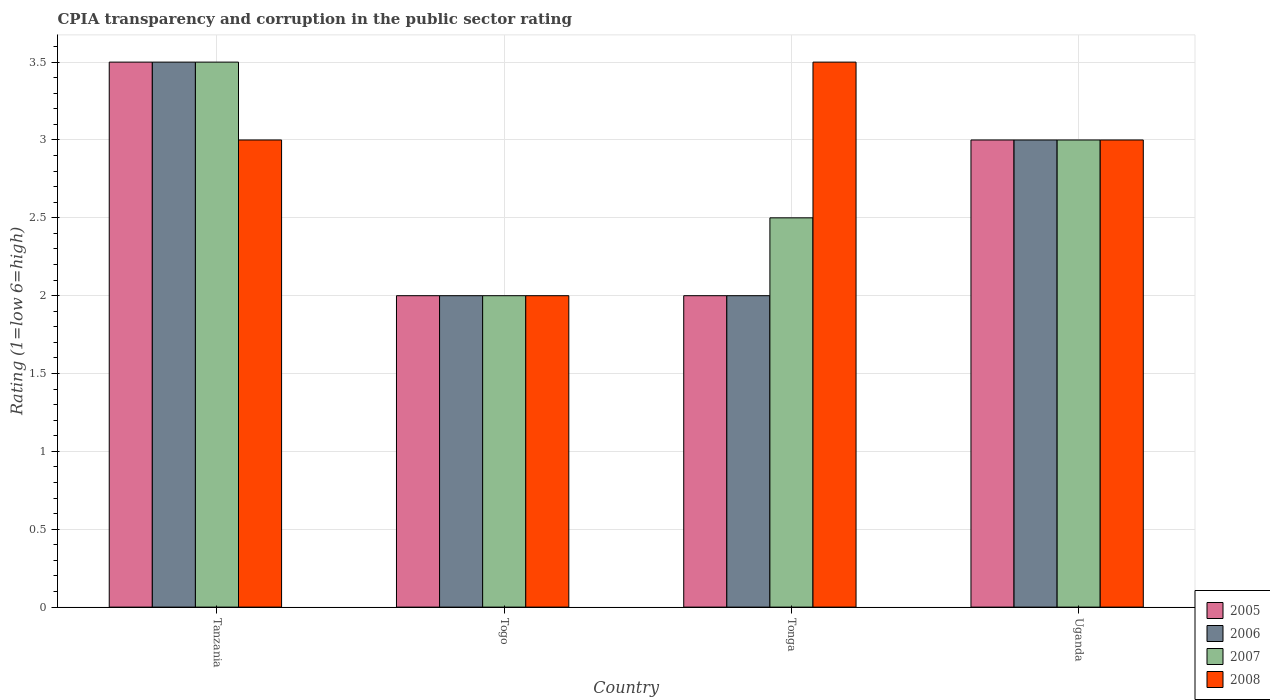How many groups of bars are there?
Offer a terse response. 4. Are the number of bars per tick equal to the number of legend labels?
Your answer should be very brief. Yes. What is the label of the 4th group of bars from the left?
Offer a very short reply. Uganda. In how many cases, is the number of bars for a given country not equal to the number of legend labels?
Give a very brief answer. 0. What is the CPIA rating in 2006 in Tonga?
Keep it short and to the point. 2. Across all countries, what is the minimum CPIA rating in 2008?
Your answer should be compact. 2. In which country was the CPIA rating in 2007 maximum?
Provide a succinct answer. Tanzania. In which country was the CPIA rating in 2007 minimum?
Your answer should be compact. Togo. What is the total CPIA rating in 2006 in the graph?
Keep it short and to the point. 10.5. What is the difference between the CPIA rating in 2005 in Tanzania and the CPIA rating in 2006 in Uganda?
Make the answer very short. 0.5. What is the average CPIA rating in 2007 per country?
Provide a succinct answer. 2.75. What is the difference between the CPIA rating of/in 2007 and CPIA rating of/in 2005 in Uganda?
Provide a short and direct response. 0. Is the difference between the CPIA rating in 2007 in Togo and Tonga greater than the difference between the CPIA rating in 2005 in Togo and Tonga?
Ensure brevity in your answer.  No. In how many countries, is the CPIA rating in 2007 greater than the average CPIA rating in 2007 taken over all countries?
Provide a short and direct response. 2. Is it the case that in every country, the sum of the CPIA rating in 2008 and CPIA rating in 2006 is greater than the sum of CPIA rating in 2007 and CPIA rating in 2005?
Make the answer very short. No. What does the 1st bar from the right in Tonga represents?
Provide a short and direct response. 2008. Is it the case that in every country, the sum of the CPIA rating in 2006 and CPIA rating in 2007 is greater than the CPIA rating in 2005?
Your answer should be compact. Yes. Are all the bars in the graph horizontal?
Make the answer very short. No. What is the difference between two consecutive major ticks on the Y-axis?
Offer a very short reply. 0.5. Does the graph contain any zero values?
Your response must be concise. No. Does the graph contain grids?
Ensure brevity in your answer.  Yes. What is the title of the graph?
Ensure brevity in your answer.  CPIA transparency and corruption in the public sector rating. What is the label or title of the X-axis?
Ensure brevity in your answer.  Country. What is the Rating (1=low 6=high) of 2006 in Tanzania?
Offer a very short reply. 3.5. What is the Rating (1=low 6=high) of 2005 in Togo?
Make the answer very short. 2. What is the Rating (1=low 6=high) of 2006 in Togo?
Provide a succinct answer. 2. What is the Rating (1=low 6=high) of 2007 in Togo?
Make the answer very short. 2. What is the Rating (1=low 6=high) of 2008 in Tonga?
Your answer should be very brief. 3.5. What is the Rating (1=low 6=high) of 2005 in Uganda?
Ensure brevity in your answer.  3. What is the Rating (1=low 6=high) of 2006 in Uganda?
Provide a short and direct response. 3. What is the Rating (1=low 6=high) in 2008 in Uganda?
Make the answer very short. 3. Across all countries, what is the maximum Rating (1=low 6=high) in 2008?
Make the answer very short. 3.5. Across all countries, what is the minimum Rating (1=low 6=high) in 2005?
Offer a terse response. 2. What is the difference between the Rating (1=low 6=high) in 2005 in Tanzania and that in Togo?
Your response must be concise. 1.5. What is the difference between the Rating (1=low 6=high) in 2007 in Tanzania and that in Togo?
Your answer should be very brief. 1.5. What is the difference between the Rating (1=low 6=high) of 2008 in Tanzania and that in Togo?
Provide a short and direct response. 1. What is the difference between the Rating (1=low 6=high) in 2006 in Tanzania and that in Tonga?
Offer a very short reply. 1.5. What is the difference between the Rating (1=low 6=high) of 2005 in Tanzania and that in Uganda?
Offer a terse response. 0.5. What is the difference between the Rating (1=low 6=high) in 2006 in Tanzania and that in Uganda?
Your answer should be very brief. 0.5. What is the difference between the Rating (1=low 6=high) in 2008 in Tanzania and that in Uganda?
Offer a terse response. 0. What is the difference between the Rating (1=low 6=high) in 2005 in Togo and that in Tonga?
Offer a terse response. 0. What is the difference between the Rating (1=low 6=high) in 2006 in Togo and that in Tonga?
Keep it short and to the point. 0. What is the difference between the Rating (1=low 6=high) of 2005 in Togo and that in Uganda?
Give a very brief answer. -1. What is the difference between the Rating (1=low 6=high) in 2006 in Togo and that in Uganda?
Provide a succinct answer. -1. What is the difference between the Rating (1=low 6=high) of 2008 in Togo and that in Uganda?
Your answer should be compact. -1. What is the difference between the Rating (1=low 6=high) of 2006 in Tonga and that in Uganda?
Your response must be concise. -1. What is the difference between the Rating (1=low 6=high) of 2005 in Tanzania and the Rating (1=low 6=high) of 2007 in Togo?
Give a very brief answer. 1.5. What is the difference between the Rating (1=low 6=high) of 2005 in Tanzania and the Rating (1=low 6=high) of 2008 in Togo?
Offer a very short reply. 1.5. What is the difference between the Rating (1=low 6=high) of 2006 in Tanzania and the Rating (1=low 6=high) of 2007 in Togo?
Your answer should be very brief. 1.5. What is the difference between the Rating (1=low 6=high) in 2005 in Tanzania and the Rating (1=low 6=high) in 2007 in Tonga?
Ensure brevity in your answer.  1. What is the difference between the Rating (1=low 6=high) in 2005 in Tanzania and the Rating (1=low 6=high) in 2008 in Tonga?
Offer a very short reply. 0. What is the difference between the Rating (1=low 6=high) of 2005 in Tanzania and the Rating (1=low 6=high) of 2007 in Uganda?
Offer a very short reply. 0.5. What is the difference between the Rating (1=low 6=high) of 2005 in Tanzania and the Rating (1=low 6=high) of 2008 in Uganda?
Provide a short and direct response. 0.5. What is the difference between the Rating (1=low 6=high) in 2006 in Tanzania and the Rating (1=low 6=high) in 2008 in Uganda?
Provide a short and direct response. 0.5. What is the difference between the Rating (1=low 6=high) of 2007 in Tanzania and the Rating (1=low 6=high) of 2008 in Uganda?
Provide a short and direct response. 0.5. What is the difference between the Rating (1=low 6=high) of 2006 in Togo and the Rating (1=low 6=high) of 2008 in Tonga?
Keep it short and to the point. -1.5. What is the difference between the Rating (1=low 6=high) of 2005 in Togo and the Rating (1=low 6=high) of 2007 in Uganda?
Keep it short and to the point. -1. What is the difference between the Rating (1=low 6=high) of 2005 in Togo and the Rating (1=low 6=high) of 2008 in Uganda?
Your response must be concise. -1. What is the difference between the Rating (1=low 6=high) in 2006 in Togo and the Rating (1=low 6=high) in 2007 in Uganda?
Make the answer very short. -1. What is the difference between the Rating (1=low 6=high) in 2006 in Togo and the Rating (1=low 6=high) in 2008 in Uganda?
Offer a terse response. -1. What is the difference between the Rating (1=low 6=high) of 2007 in Togo and the Rating (1=low 6=high) of 2008 in Uganda?
Make the answer very short. -1. What is the difference between the Rating (1=low 6=high) of 2005 in Tonga and the Rating (1=low 6=high) of 2006 in Uganda?
Ensure brevity in your answer.  -1. What is the difference between the Rating (1=low 6=high) of 2005 in Tonga and the Rating (1=low 6=high) of 2007 in Uganda?
Give a very brief answer. -1. What is the difference between the Rating (1=low 6=high) of 2005 in Tonga and the Rating (1=low 6=high) of 2008 in Uganda?
Ensure brevity in your answer.  -1. What is the average Rating (1=low 6=high) of 2005 per country?
Keep it short and to the point. 2.62. What is the average Rating (1=low 6=high) of 2006 per country?
Your response must be concise. 2.62. What is the average Rating (1=low 6=high) of 2007 per country?
Your answer should be very brief. 2.75. What is the average Rating (1=low 6=high) of 2008 per country?
Provide a succinct answer. 2.88. What is the difference between the Rating (1=low 6=high) in 2005 and Rating (1=low 6=high) in 2006 in Tanzania?
Give a very brief answer. 0. What is the difference between the Rating (1=low 6=high) of 2005 and Rating (1=low 6=high) of 2008 in Tanzania?
Make the answer very short. 0.5. What is the difference between the Rating (1=low 6=high) of 2007 and Rating (1=low 6=high) of 2008 in Tanzania?
Your response must be concise. 0.5. What is the difference between the Rating (1=low 6=high) in 2005 and Rating (1=low 6=high) in 2007 in Togo?
Keep it short and to the point. 0. What is the difference between the Rating (1=low 6=high) of 2007 and Rating (1=low 6=high) of 2008 in Togo?
Keep it short and to the point. 0. What is the difference between the Rating (1=low 6=high) of 2006 and Rating (1=low 6=high) of 2007 in Tonga?
Your answer should be compact. -0.5. What is the difference between the Rating (1=low 6=high) of 2005 and Rating (1=low 6=high) of 2006 in Uganda?
Your answer should be very brief. 0. What is the difference between the Rating (1=low 6=high) of 2005 and Rating (1=low 6=high) of 2007 in Uganda?
Make the answer very short. 0. What is the difference between the Rating (1=low 6=high) in 2005 and Rating (1=low 6=high) in 2008 in Uganda?
Provide a succinct answer. 0. What is the difference between the Rating (1=low 6=high) of 2006 and Rating (1=low 6=high) of 2008 in Uganda?
Offer a very short reply. 0. What is the difference between the Rating (1=low 6=high) in 2007 and Rating (1=low 6=high) in 2008 in Uganda?
Ensure brevity in your answer.  0. What is the ratio of the Rating (1=low 6=high) in 2005 in Tanzania to that in Togo?
Provide a succinct answer. 1.75. What is the ratio of the Rating (1=low 6=high) in 2006 in Tanzania to that in Togo?
Offer a terse response. 1.75. What is the ratio of the Rating (1=low 6=high) of 2005 in Tanzania to that in Tonga?
Give a very brief answer. 1.75. What is the ratio of the Rating (1=low 6=high) of 2006 in Tanzania to that in Tonga?
Provide a succinct answer. 1.75. What is the ratio of the Rating (1=low 6=high) of 2008 in Tanzania to that in Tonga?
Your answer should be very brief. 0.86. What is the ratio of the Rating (1=low 6=high) of 2005 in Tanzania to that in Uganda?
Ensure brevity in your answer.  1.17. What is the ratio of the Rating (1=low 6=high) of 2007 in Tanzania to that in Uganda?
Your response must be concise. 1.17. What is the ratio of the Rating (1=low 6=high) in 2008 in Tanzania to that in Uganda?
Your answer should be very brief. 1. What is the ratio of the Rating (1=low 6=high) in 2006 in Togo to that in Tonga?
Your answer should be compact. 1. What is the ratio of the Rating (1=low 6=high) in 2005 in Togo to that in Uganda?
Make the answer very short. 0.67. What is the ratio of the Rating (1=low 6=high) of 2006 in Togo to that in Uganda?
Make the answer very short. 0.67. What is the ratio of the Rating (1=low 6=high) of 2008 in Togo to that in Uganda?
Keep it short and to the point. 0.67. What is the ratio of the Rating (1=low 6=high) of 2005 in Tonga to that in Uganda?
Provide a succinct answer. 0.67. What is the ratio of the Rating (1=low 6=high) of 2006 in Tonga to that in Uganda?
Keep it short and to the point. 0.67. What is the ratio of the Rating (1=low 6=high) in 2007 in Tonga to that in Uganda?
Make the answer very short. 0.83. What is the difference between the highest and the second highest Rating (1=low 6=high) of 2008?
Provide a succinct answer. 0.5. What is the difference between the highest and the lowest Rating (1=low 6=high) of 2007?
Provide a succinct answer. 1.5. 